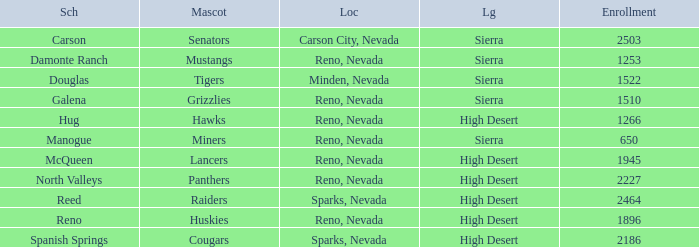Which school has the Raiders as their mascot? Reed. 